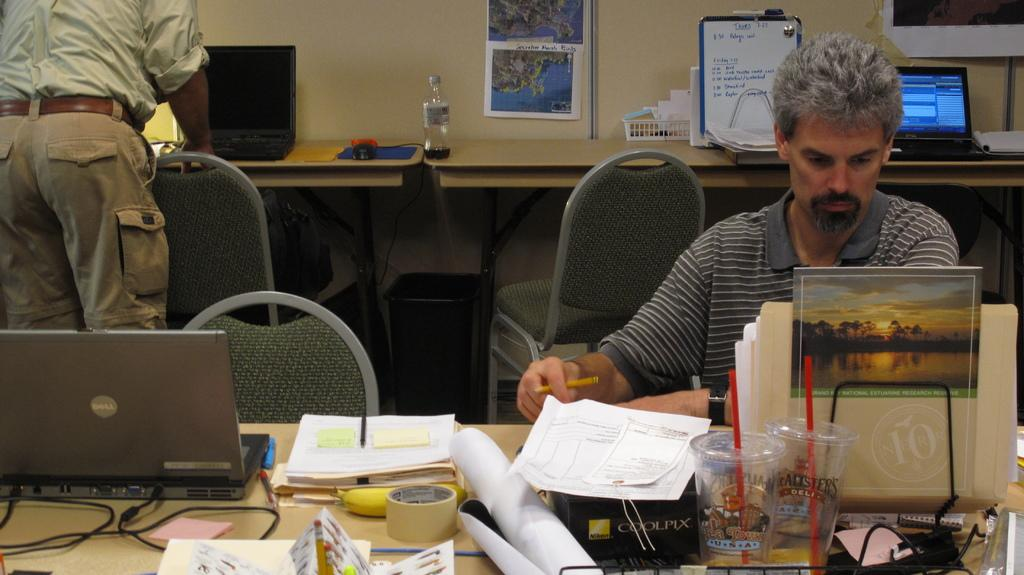What is the man in the image doing? There is a man seated on a chair in the image. What objects are on the table in the image? There are papers, a laptop, and glasses on a table in the image. Can you describe the position of the standing man in the image? There is a man standing in the image. What type of low songs can be heard in the background of the image? There is no mention of music or songs in the image, so it is not possible to determine if any songs can be heard in the background. 